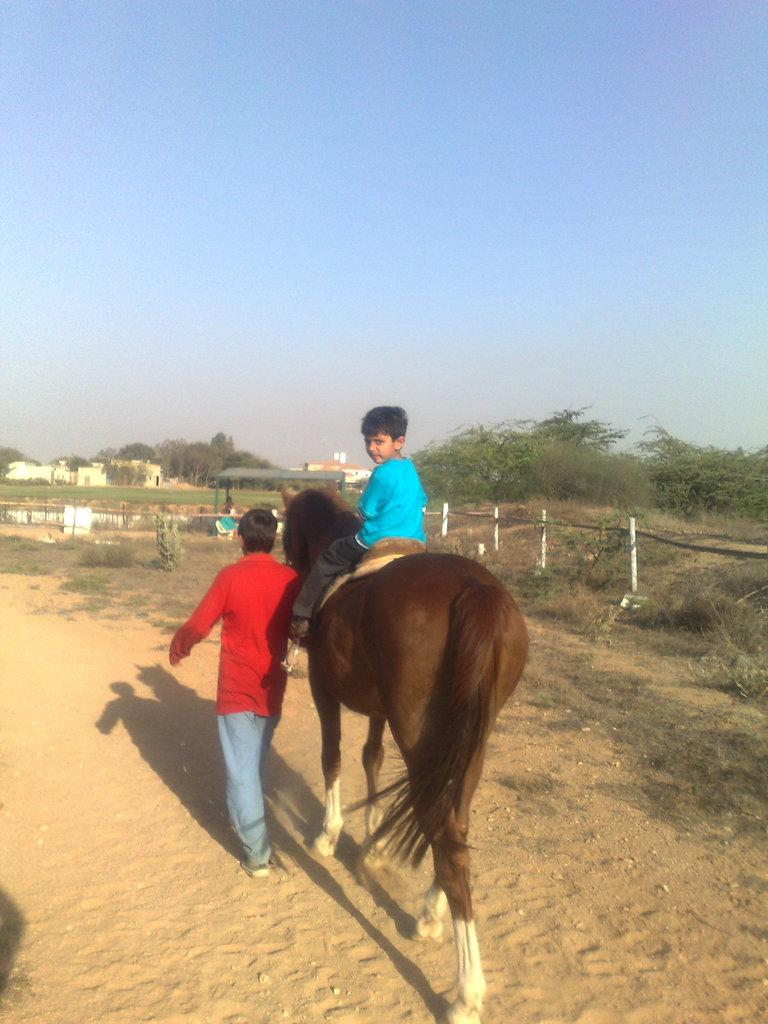Who is the main subject in the image? The main subject in the image is a boy. What is the boy wearing? The boy is wearing a blue t-shirt. What is the boy doing in the image? The boy is sitting on a horse. Who else is present in the image? There is a man in the image. What is the man wearing? The man is wearing a red t-shirt. What is the man doing in the image? The man is walking along with the horse. What can be seen on the right side of the image? There are grass and trees on the right side of the image. What is the color of the sky in the image? The sky is blue. What type of pet can be seen playing with a toothbrush in the image? There is no pet or toothbrush present in the image. 